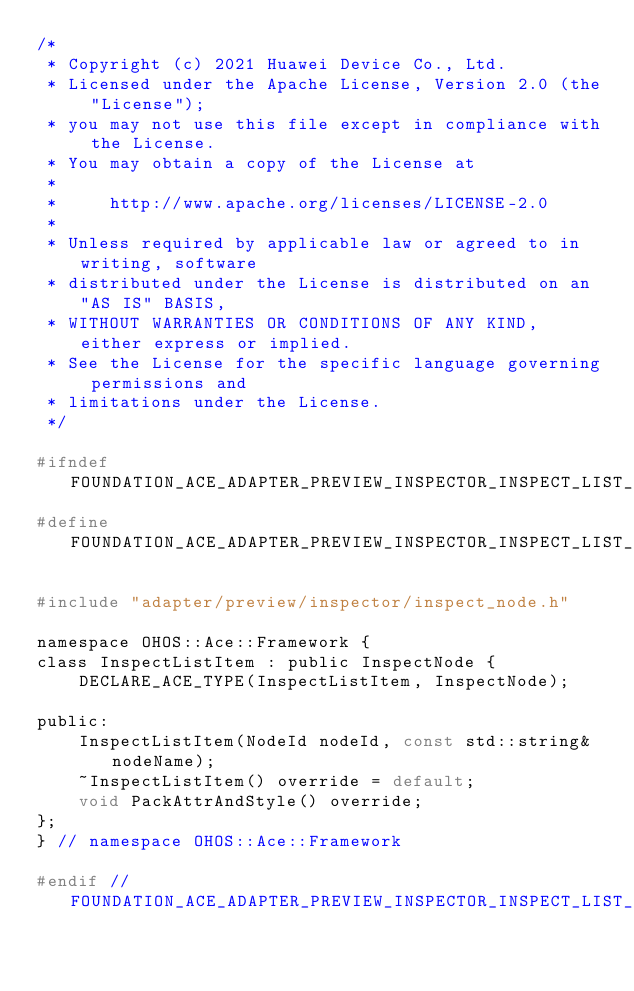<code> <loc_0><loc_0><loc_500><loc_500><_C_>/*
 * Copyright (c) 2021 Huawei Device Co., Ltd.
 * Licensed under the Apache License, Version 2.0 (the "License");
 * you may not use this file except in compliance with the License.
 * You may obtain a copy of the License at
 *
 *     http://www.apache.org/licenses/LICENSE-2.0
 *
 * Unless required by applicable law or agreed to in writing, software
 * distributed under the License is distributed on an "AS IS" BASIS,
 * WITHOUT WARRANTIES OR CONDITIONS OF ANY KIND, either express or implied.
 * See the License for the specific language governing permissions and
 * limitations under the License.
 */

#ifndef FOUNDATION_ACE_ADAPTER_PREVIEW_INSPECTOR_INSPECT_LIST_ITEM_H
#define FOUNDATION_ACE_ADAPTER_PREVIEW_INSPECTOR_INSPECT_LIST_ITEM_H

#include "adapter/preview/inspector/inspect_node.h"

namespace OHOS::Ace::Framework {
class InspectListItem : public InspectNode {
    DECLARE_ACE_TYPE(InspectListItem, InspectNode);

public:
    InspectListItem(NodeId nodeId, const std::string& nodeName);
    ~InspectListItem() override = default;
    void PackAttrAndStyle() override;
};
} // namespace OHOS::Ace::Framework

#endif // FOUNDATION_ACE_ADAPTER_PREVIEW_INSPECTOR_INSPECT_LIST_ITEM_H
</code> 